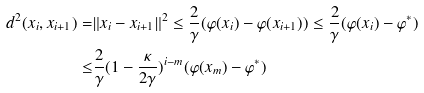<formula> <loc_0><loc_0><loc_500><loc_500>d ^ { 2 } ( x _ { i } , x _ { i + 1 } ) = & \| x _ { i } - x _ { i + 1 } \| ^ { 2 } \leq \frac { 2 } { \gamma } ( \varphi ( x _ { i } ) - \varphi ( x _ { i + 1 } ) ) \leq \frac { 2 } { \gamma } ( \varphi ( x _ { i } ) - \varphi ^ { * } ) \\ \leq & \frac { 2 } { \gamma } ( 1 - \frac { \kappa } { 2 \gamma } ) ^ { i - m } ( \varphi ( x _ { m } ) - \varphi ^ { * } )</formula> 